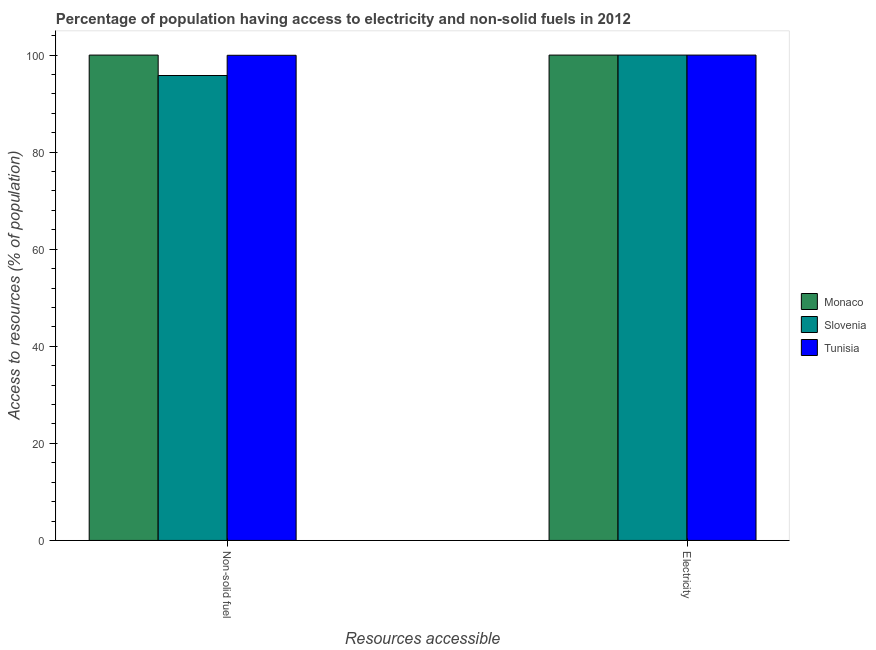How many groups of bars are there?
Your response must be concise. 2. Are the number of bars per tick equal to the number of legend labels?
Keep it short and to the point. Yes. What is the label of the 2nd group of bars from the left?
Provide a short and direct response. Electricity. What is the percentage of population having access to electricity in Tunisia?
Ensure brevity in your answer.  100. Across all countries, what is the maximum percentage of population having access to electricity?
Make the answer very short. 100. Across all countries, what is the minimum percentage of population having access to electricity?
Offer a terse response. 100. In which country was the percentage of population having access to non-solid fuel maximum?
Give a very brief answer. Monaco. In which country was the percentage of population having access to electricity minimum?
Your answer should be very brief. Monaco. What is the total percentage of population having access to electricity in the graph?
Your answer should be compact. 300. What is the difference between the percentage of population having access to non-solid fuel in Slovenia and that in Monaco?
Ensure brevity in your answer.  -4.21. What is the difference between the percentage of population having access to electricity in Monaco and the percentage of population having access to non-solid fuel in Slovenia?
Offer a terse response. 4.21. What is the average percentage of population having access to non-solid fuel per country?
Give a very brief answer. 98.58. What is the difference between the percentage of population having access to electricity and percentage of population having access to non-solid fuel in Tunisia?
Offer a terse response. 0.04. What does the 2nd bar from the left in Electricity represents?
Offer a terse response. Slovenia. What does the 1st bar from the right in Non-solid fuel represents?
Give a very brief answer. Tunisia. How many bars are there?
Provide a short and direct response. 6. How many countries are there in the graph?
Offer a very short reply. 3. What is the difference between two consecutive major ticks on the Y-axis?
Offer a very short reply. 20. Are the values on the major ticks of Y-axis written in scientific E-notation?
Your answer should be compact. No. How are the legend labels stacked?
Give a very brief answer. Vertical. What is the title of the graph?
Give a very brief answer. Percentage of population having access to electricity and non-solid fuels in 2012. Does "Serbia" appear as one of the legend labels in the graph?
Offer a very short reply. No. What is the label or title of the X-axis?
Provide a short and direct response. Resources accessible. What is the label or title of the Y-axis?
Offer a very short reply. Access to resources (% of population). What is the Access to resources (% of population) in Slovenia in Non-solid fuel?
Keep it short and to the point. 95.79. What is the Access to resources (% of population) in Tunisia in Non-solid fuel?
Keep it short and to the point. 99.96. What is the Access to resources (% of population) of Monaco in Electricity?
Ensure brevity in your answer.  100. What is the Access to resources (% of population) in Slovenia in Electricity?
Keep it short and to the point. 100. What is the Access to resources (% of population) of Tunisia in Electricity?
Make the answer very short. 100. Across all Resources accessible, what is the maximum Access to resources (% of population) in Tunisia?
Provide a short and direct response. 100. Across all Resources accessible, what is the minimum Access to resources (% of population) in Slovenia?
Provide a short and direct response. 95.79. Across all Resources accessible, what is the minimum Access to resources (% of population) of Tunisia?
Your answer should be compact. 99.96. What is the total Access to resources (% of population) in Monaco in the graph?
Your response must be concise. 200. What is the total Access to resources (% of population) of Slovenia in the graph?
Provide a succinct answer. 195.79. What is the total Access to resources (% of population) in Tunisia in the graph?
Offer a very short reply. 199.96. What is the difference between the Access to resources (% of population) of Slovenia in Non-solid fuel and that in Electricity?
Offer a terse response. -4.21. What is the difference between the Access to resources (% of population) in Tunisia in Non-solid fuel and that in Electricity?
Make the answer very short. -0.04. What is the difference between the Access to resources (% of population) of Monaco in Non-solid fuel and the Access to resources (% of population) of Slovenia in Electricity?
Offer a terse response. 0. What is the difference between the Access to resources (% of population) in Monaco in Non-solid fuel and the Access to resources (% of population) in Tunisia in Electricity?
Make the answer very short. 0. What is the difference between the Access to resources (% of population) of Slovenia in Non-solid fuel and the Access to resources (% of population) of Tunisia in Electricity?
Keep it short and to the point. -4.21. What is the average Access to resources (% of population) of Monaco per Resources accessible?
Provide a succinct answer. 100. What is the average Access to resources (% of population) of Slovenia per Resources accessible?
Give a very brief answer. 97.9. What is the average Access to resources (% of population) of Tunisia per Resources accessible?
Your answer should be very brief. 99.98. What is the difference between the Access to resources (% of population) in Monaco and Access to resources (% of population) in Slovenia in Non-solid fuel?
Your answer should be very brief. 4.21. What is the difference between the Access to resources (% of population) of Monaco and Access to resources (% of population) of Tunisia in Non-solid fuel?
Give a very brief answer. 0.04. What is the difference between the Access to resources (% of population) of Slovenia and Access to resources (% of population) of Tunisia in Non-solid fuel?
Your answer should be compact. -4.17. What is the difference between the Access to resources (% of population) of Slovenia and Access to resources (% of population) of Tunisia in Electricity?
Keep it short and to the point. 0. What is the ratio of the Access to resources (% of population) of Monaco in Non-solid fuel to that in Electricity?
Make the answer very short. 1. What is the ratio of the Access to resources (% of population) of Slovenia in Non-solid fuel to that in Electricity?
Make the answer very short. 0.96. What is the ratio of the Access to resources (% of population) in Tunisia in Non-solid fuel to that in Electricity?
Your answer should be compact. 1. What is the difference between the highest and the second highest Access to resources (% of population) in Monaco?
Ensure brevity in your answer.  0. What is the difference between the highest and the second highest Access to resources (% of population) of Slovenia?
Make the answer very short. 4.21. What is the difference between the highest and the second highest Access to resources (% of population) of Tunisia?
Keep it short and to the point. 0.04. What is the difference between the highest and the lowest Access to resources (% of population) of Slovenia?
Offer a terse response. 4.21. What is the difference between the highest and the lowest Access to resources (% of population) of Tunisia?
Give a very brief answer. 0.04. 